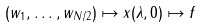Convert formula to latex. <formula><loc_0><loc_0><loc_500><loc_500>( w _ { 1 } , \dots , w _ { N / 2 } ) \mapsto x ( \lambda , 0 ) \mapsto f</formula> 